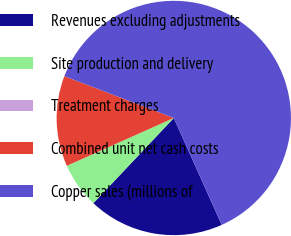Convert chart. <chart><loc_0><loc_0><loc_500><loc_500><pie_chart><fcel>Revenues excluding adjustments<fcel>Site production and delivery<fcel>Treatment charges<fcel>Combined unit net cash costs<fcel>Copper sales (millions of<nl><fcel>18.75%<fcel>6.26%<fcel>0.01%<fcel>12.5%<fcel>62.48%<nl></chart> 